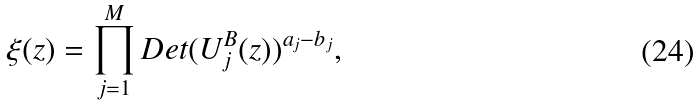<formula> <loc_0><loc_0><loc_500><loc_500>\xi ( z ) = \prod _ { j = 1 } ^ { M } D e t ( U _ { j } ^ { B } ( z ) ) ^ { a _ { j } - b _ { j } } ,</formula> 